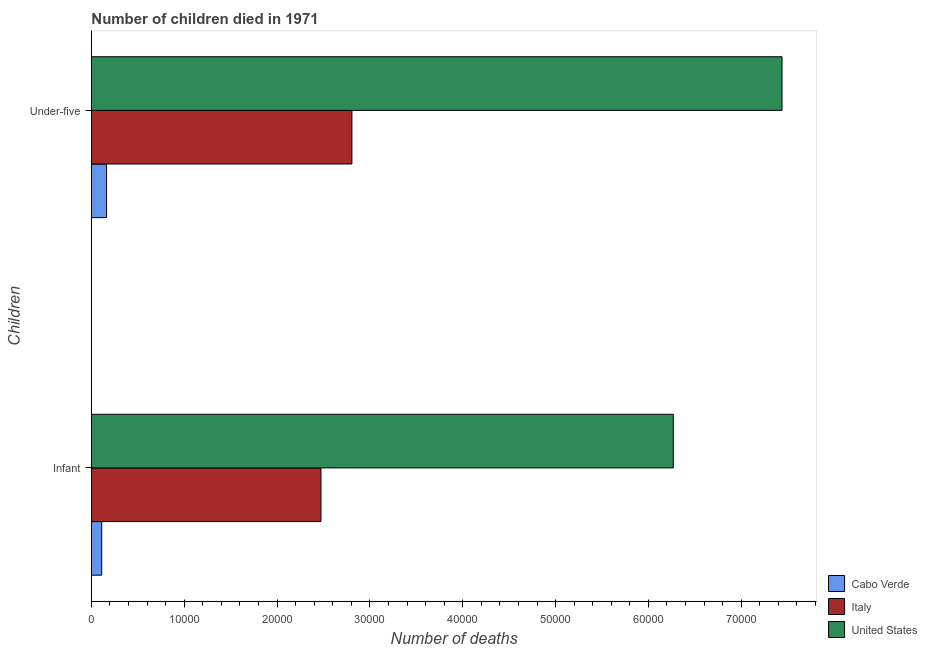Are the number of bars per tick equal to the number of legend labels?
Give a very brief answer. Yes. Are the number of bars on each tick of the Y-axis equal?
Offer a terse response. Yes. How many bars are there on the 1st tick from the bottom?
Make the answer very short. 3. What is the label of the 1st group of bars from the top?
Ensure brevity in your answer.  Under-five. What is the number of under-five deaths in Cabo Verde?
Keep it short and to the point. 1630. Across all countries, what is the maximum number of under-five deaths?
Make the answer very short. 7.44e+04. Across all countries, what is the minimum number of infant deaths?
Your answer should be compact. 1107. In which country was the number of infant deaths maximum?
Your answer should be compact. United States. In which country was the number of infant deaths minimum?
Your answer should be compact. Cabo Verde. What is the total number of infant deaths in the graph?
Your answer should be compact. 8.85e+04. What is the difference between the number of under-five deaths in Cabo Verde and that in United States?
Provide a short and direct response. -7.28e+04. What is the difference between the number of infant deaths in United States and the number of under-five deaths in Cabo Verde?
Your response must be concise. 6.10e+04. What is the average number of under-five deaths per country?
Keep it short and to the point. 3.47e+04. What is the difference between the number of under-five deaths and number of infant deaths in Italy?
Provide a succinct answer. 3336. In how many countries, is the number of under-five deaths greater than 42000 ?
Keep it short and to the point. 1. What is the ratio of the number of infant deaths in Cabo Verde to that in Italy?
Keep it short and to the point. 0.04. Is the number of under-five deaths in United States less than that in Italy?
Your response must be concise. No. In how many countries, is the number of under-five deaths greater than the average number of under-five deaths taken over all countries?
Your answer should be compact. 1. What does the 1st bar from the top in Under-five represents?
Ensure brevity in your answer.  United States. What does the 1st bar from the bottom in Under-five represents?
Your response must be concise. Cabo Verde. How many countries are there in the graph?
Offer a terse response. 3. What is the difference between two consecutive major ticks on the X-axis?
Make the answer very short. 10000. Are the values on the major ticks of X-axis written in scientific E-notation?
Provide a succinct answer. No. What is the title of the graph?
Offer a very short reply. Number of children died in 1971. Does "Guyana" appear as one of the legend labels in the graph?
Provide a succinct answer. No. What is the label or title of the X-axis?
Give a very brief answer. Number of deaths. What is the label or title of the Y-axis?
Your answer should be compact. Children. What is the Number of deaths of Cabo Verde in Infant?
Keep it short and to the point. 1107. What is the Number of deaths in Italy in Infant?
Your answer should be compact. 2.47e+04. What is the Number of deaths in United States in Infant?
Provide a short and direct response. 6.27e+04. What is the Number of deaths in Cabo Verde in Under-five?
Ensure brevity in your answer.  1630. What is the Number of deaths in Italy in Under-five?
Provide a succinct answer. 2.81e+04. What is the Number of deaths in United States in Under-five?
Provide a succinct answer. 7.44e+04. Across all Children, what is the maximum Number of deaths in Cabo Verde?
Give a very brief answer. 1630. Across all Children, what is the maximum Number of deaths in Italy?
Provide a succinct answer. 2.81e+04. Across all Children, what is the maximum Number of deaths in United States?
Your response must be concise. 7.44e+04. Across all Children, what is the minimum Number of deaths in Cabo Verde?
Provide a succinct answer. 1107. Across all Children, what is the minimum Number of deaths of Italy?
Provide a succinct answer. 2.47e+04. Across all Children, what is the minimum Number of deaths of United States?
Your response must be concise. 6.27e+04. What is the total Number of deaths of Cabo Verde in the graph?
Provide a short and direct response. 2737. What is the total Number of deaths of Italy in the graph?
Provide a short and direct response. 5.28e+04. What is the total Number of deaths of United States in the graph?
Your response must be concise. 1.37e+05. What is the difference between the Number of deaths in Cabo Verde in Infant and that in Under-five?
Ensure brevity in your answer.  -523. What is the difference between the Number of deaths of Italy in Infant and that in Under-five?
Make the answer very short. -3336. What is the difference between the Number of deaths of United States in Infant and that in Under-five?
Offer a very short reply. -1.17e+04. What is the difference between the Number of deaths in Cabo Verde in Infant and the Number of deaths in Italy in Under-five?
Offer a terse response. -2.70e+04. What is the difference between the Number of deaths in Cabo Verde in Infant and the Number of deaths in United States in Under-five?
Make the answer very short. -7.33e+04. What is the difference between the Number of deaths of Italy in Infant and the Number of deaths of United States in Under-five?
Offer a terse response. -4.97e+04. What is the average Number of deaths in Cabo Verde per Children?
Provide a short and direct response. 1368.5. What is the average Number of deaths of Italy per Children?
Offer a very short reply. 2.64e+04. What is the average Number of deaths of United States per Children?
Provide a succinct answer. 6.85e+04. What is the difference between the Number of deaths of Cabo Verde and Number of deaths of Italy in Infant?
Your answer should be compact. -2.36e+04. What is the difference between the Number of deaths in Cabo Verde and Number of deaths in United States in Infant?
Provide a short and direct response. -6.16e+04. What is the difference between the Number of deaths of Italy and Number of deaths of United States in Infant?
Provide a succinct answer. -3.80e+04. What is the difference between the Number of deaths of Cabo Verde and Number of deaths of Italy in Under-five?
Your answer should be compact. -2.64e+04. What is the difference between the Number of deaths of Cabo Verde and Number of deaths of United States in Under-five?
Ensure brevity in your answer.  -7.28e+04. What is the difference between the Number of deaths of Italy and Number of deaths of United States in Under-five?
Your answer should be compact. -4.63e+04. What is the ratio of the Number of deaths of Cabo Verde in Infant to that in Under-five?
Your response must be concise. 0.68. What is the ratio of the Number of deaths in Italy in Infant to that in Under-five?
Your response must be concise. 0.88. What is the ratio of the Number of deaths of United States in Infant to that in Under-five?
Offer a terse response. 0.84. What is the difference between the highest and the second highest Number of deaths in Cabo Verde?
Offer a very short reply. 523. What is the difference between the highest and the second highest Number of deaths of Italy?
Your answer should be compact. 3336. What is the difference between the highest and the second highest Number of deaths in United States?
Your answer should be very brief. 1.17e+04. What is the difference between the highest and the lowest Number of deaths of Cabo Verde?
Your answer should be very brief. 523. What is the difference between the highest and the lowest Number of deaths of Italy?
Keep it short and to the point. 3336. What is the difference between the highest and the lowest Number of deaths of United States?
Your response must be concise. 1.17e+04. 